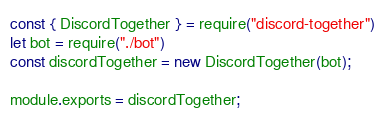<code> <loc_0><loc_0><loc_500><loc_500><_JavaScript_>const { DiscordTogether } = require("discord-together")
let bot = require("./bot")
const discordTogether = new DiscordTogether(bot);

module.exports = discordTogether;</code> 